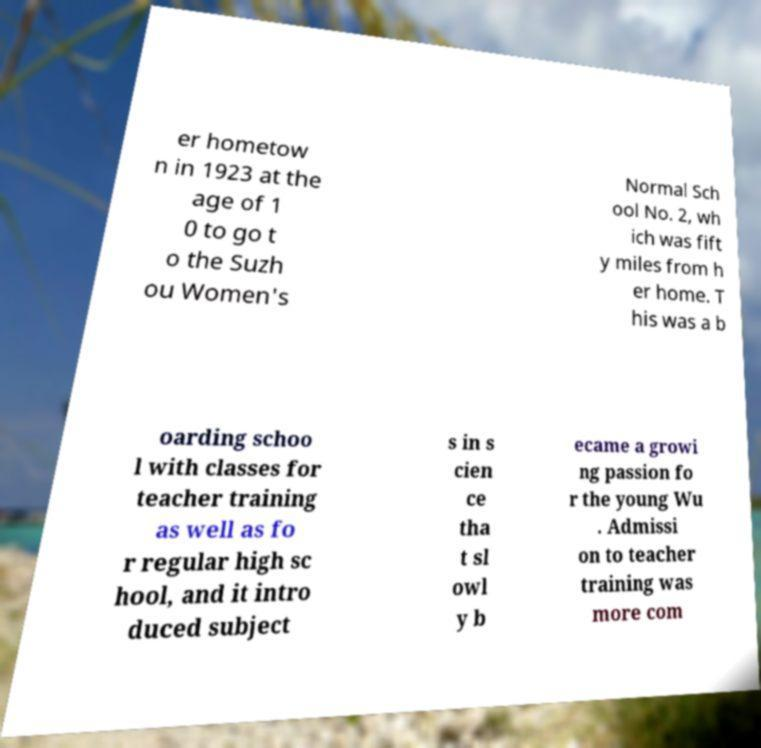Please identify and transcribe the text found in this image. er hometow n in 1923 at the age of 1 0 to go t o the Suzh ou Women's Normal Sch ool No. 2, wh ich was fift y miles from h er home. T his was a b oarding schoo l with classes for teacher training as well as fo r regular high sc hool, and it intro duced subject s in s cien ce tha t sl owl y b ecame a growi ng passion fo r the young Wu . Admissi on to teacher training was more com 